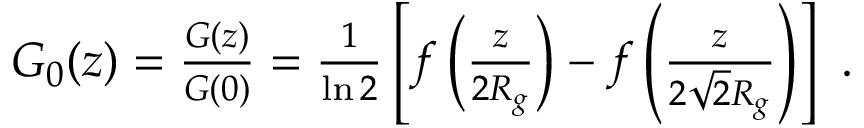<formula> <loc_0><loc_0><loc_500><loc_500>\begin{array} { r } { G _ { 0 } ( z ) = \frac { G ( z ) } { G ( 0 ) } = \frac { 1 } { \ln 2 } \left [ f \left ( \frac { z } { 2 R _ { g } } \right ) - f \left ( \frac { z } { 2 \sqrt { 2 } R _ { g } } \right ) \right ] . } \end{array}</formula> 